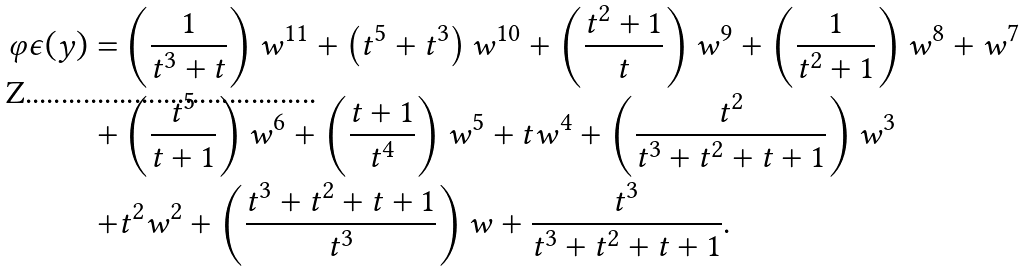<formula> <loc_0><loc_0><loc_500><loc_500>\varphi \epsilon ( y ) = & \left ( \frac { 1 } { t ^ { 3 } + t } \right ) w ^ { 1 1 } + \left ( t ^ { 5 } + t ^ { 3 } \right ) w ^ { 1 0 } + \left ( \frac { t ^ { 2 } + 1 } { t } \right ) w ^ { 9 } + \left ( \frac { 1 } { t ^ { 2 } + 1 } \right ) w ^ { 8 } + w ^ { 7 } \\ + & \left ( \frac { t ^ { 5 } } { t + 1 } \right ) w ^ { 6 } + \left ( \frac { t + 1 } { t ^ { 4 } } \right ) w ^ { 5 } + t w ^ { 4 } + \left ( \frac { t ^ { 2 } } { t ^ { 3 } + t ^ { 2 } + t + 1 } \right ) w ^ { 3 } \\ + & t ^ { 2 } w ^ { 2 } + \left ( \frac { t ^ { 3 } + t ^ { 2 } + t + 1 } { t ^ { 3 } } \right ) w + \frac { t ^ { 3 } } { t ^ { 3 } + t ^ { 2 } + t + 1 } .</formula> 